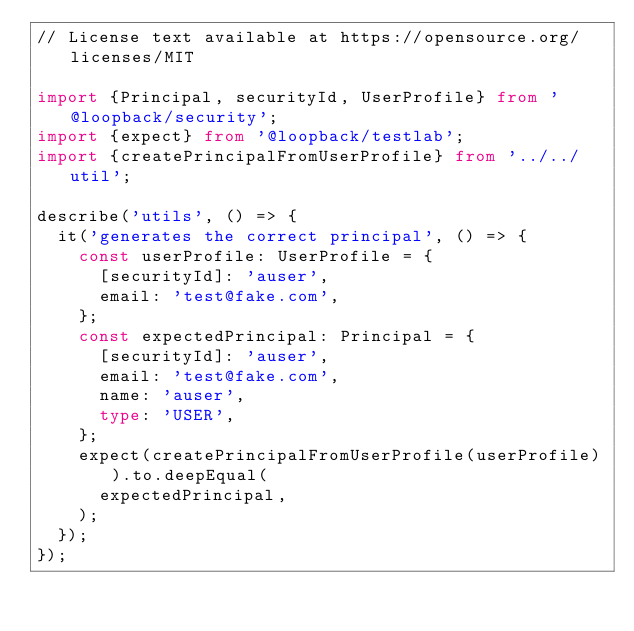<code> <loc_0><loc_0><loc_500><loc_500><_TypeScript_>// License text available at https://opensource.org/licenses/MIT

import {Principal, securityId, UserProfile} from '@loopback/security';
import {expect} from '@loopback/testlab';
import {createPrincipalFromUserProfile} from '../../util';

describe('utils', () => {
  it('generates the correct principal', () => {
    const userProfile: UserProfile = {
      [securityId]: 'auser',
      email: 'test@fake.com',
    };
    const expectedPrincipal: Principal = {
      [securityId]: 'auser',
      email: 'test@fake.com',
      name: 'auser',
      type: 'USER',
    };
    expect(createPrincipalFromUserProfile(userProfile)).to.deepEqual(
      expectedPrincipal,
    );
  });
});
</code> 